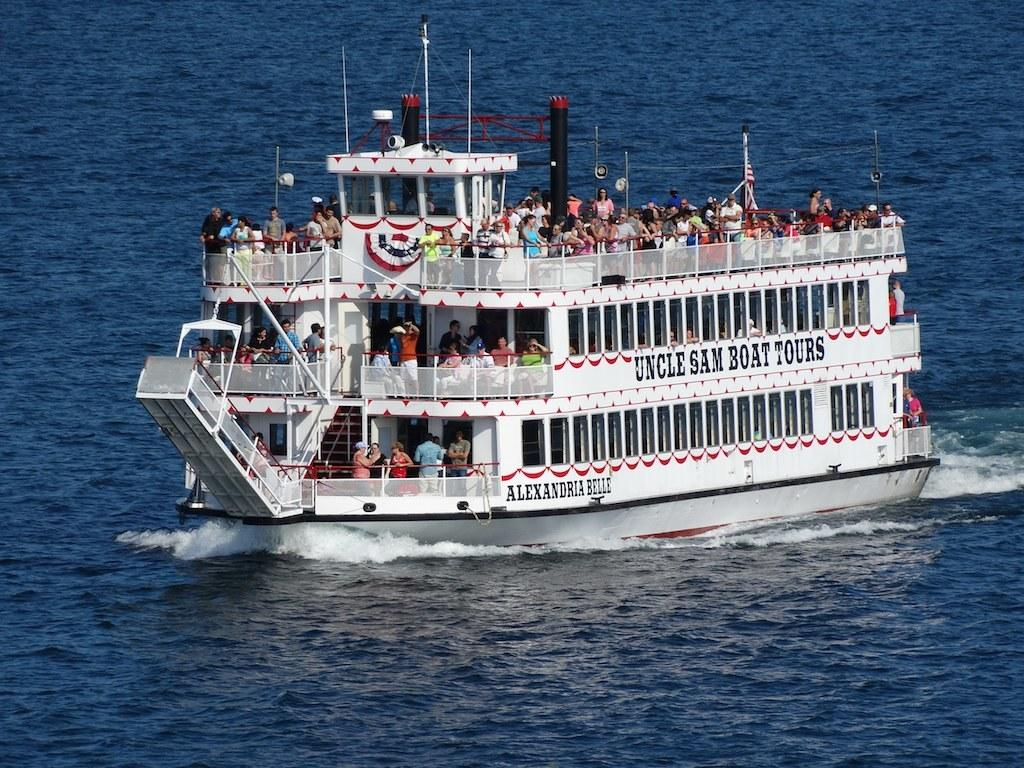What is the main subject in the center of the image? There is a big ship in the center of the image. Where is the ship located? The ship is in the water. Can you describe the people on the ship? There are many people in the ship. What can be seen around the area of the image? There is water visible around the area of the image. What type of grain is being harvested on the ship in the image? There is no grain being harvested on the ship in the image; it is a ship in the water with many people on board. 